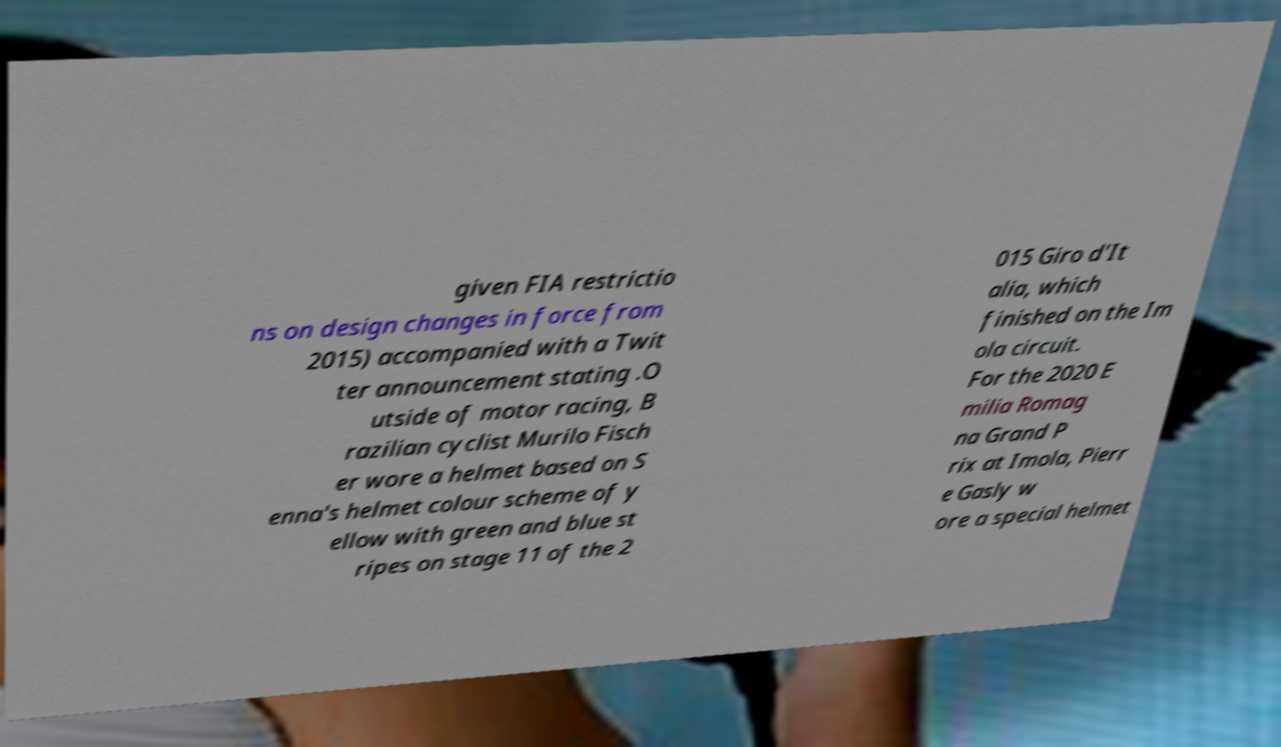I need the written content from this picture converted into text. Can you do that? given FIA restrictio ns on design changes in force from 2015) accompanied with a Twit ter announcement stating .O utside of motor racing, B razilian cyclist Murilo Fisch er wore a helmet based on S enna's helmet colour scheme of y ellow with green and blue st ripes on stage 11 of the 2 015 Giro d'It alia, which finished on the Im ola circuit. For the 2020 E milia Romag na Grand P rix at Imola, Pierr e Gasly w ore a special helmet 